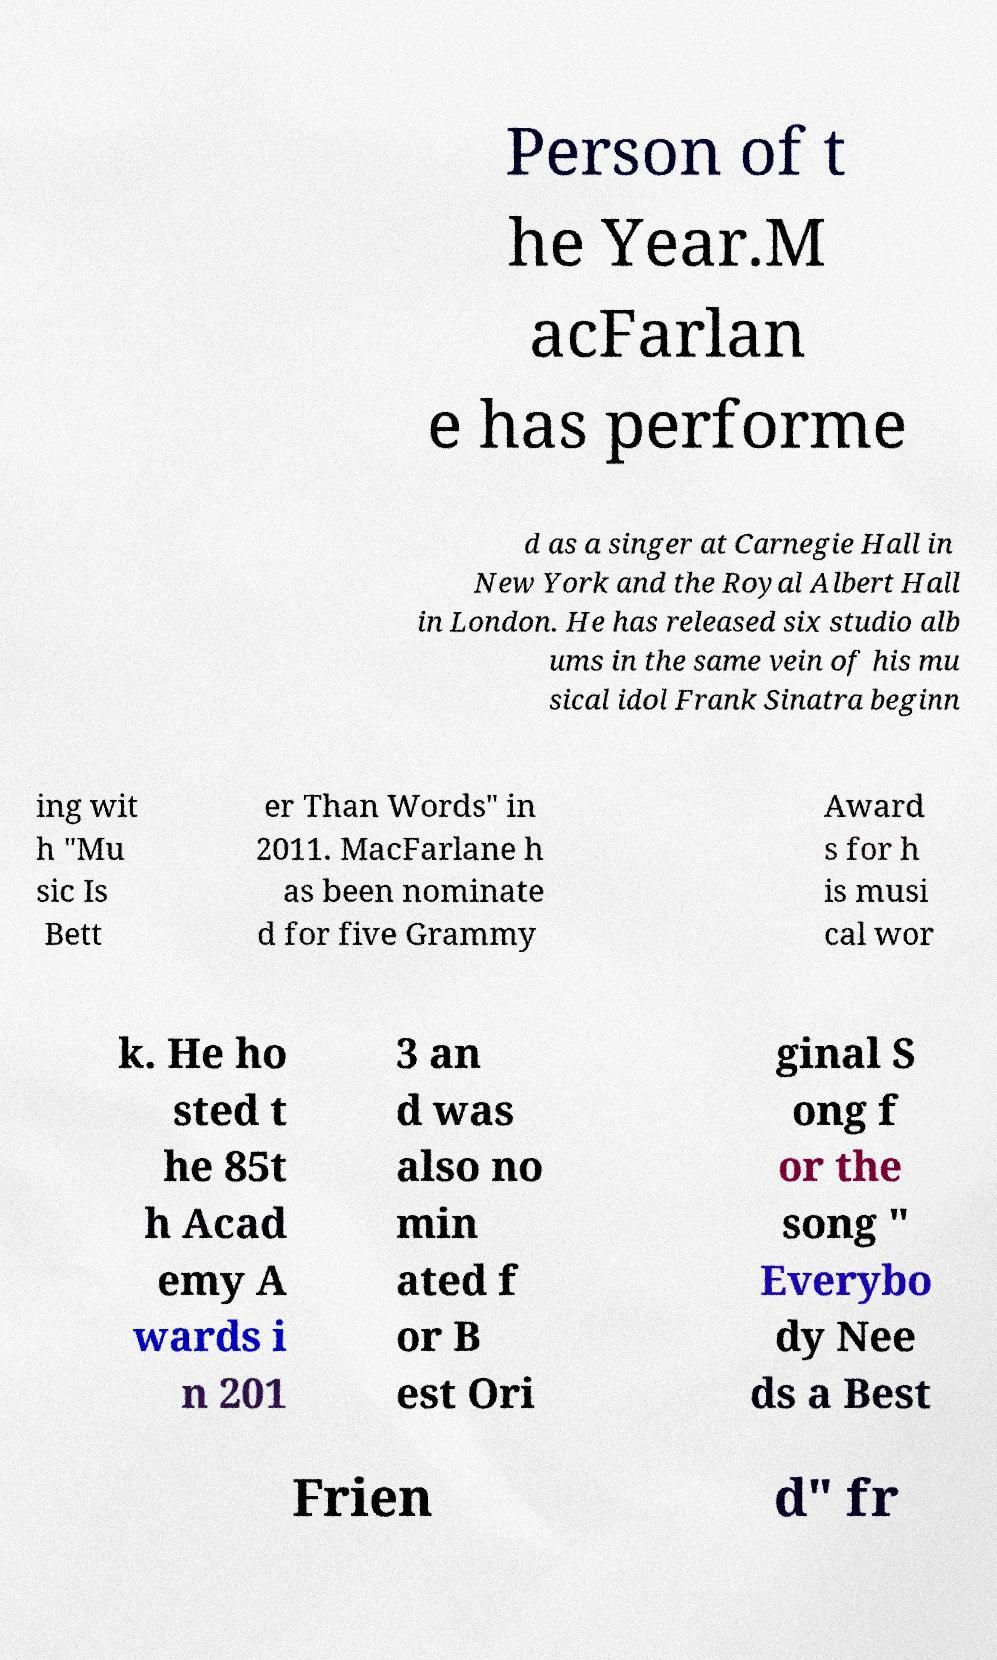What messages or text are displayed in this image? I need them in a readable, typed format. Person of t he Year.M acFarlan e has performe d as a singer at Carnegie Hall in New York and the Royal Albert Hall in London. He has released six studio alb ums in the same vein of his mu sical idol Frank Sinatra beginn ing wit h "Mu sic Is Bett er Than Words" in 2011. MacFarlane h as been nominate d for five Grammy Award s for h is musi cal wor k. He ho sted t he 85t h Acad emy A wards i n 201 3 an d was also no min ated f or B est Ori ginal S ong f or the song " Everybo dy Nee ds a Best Frien d" fr 